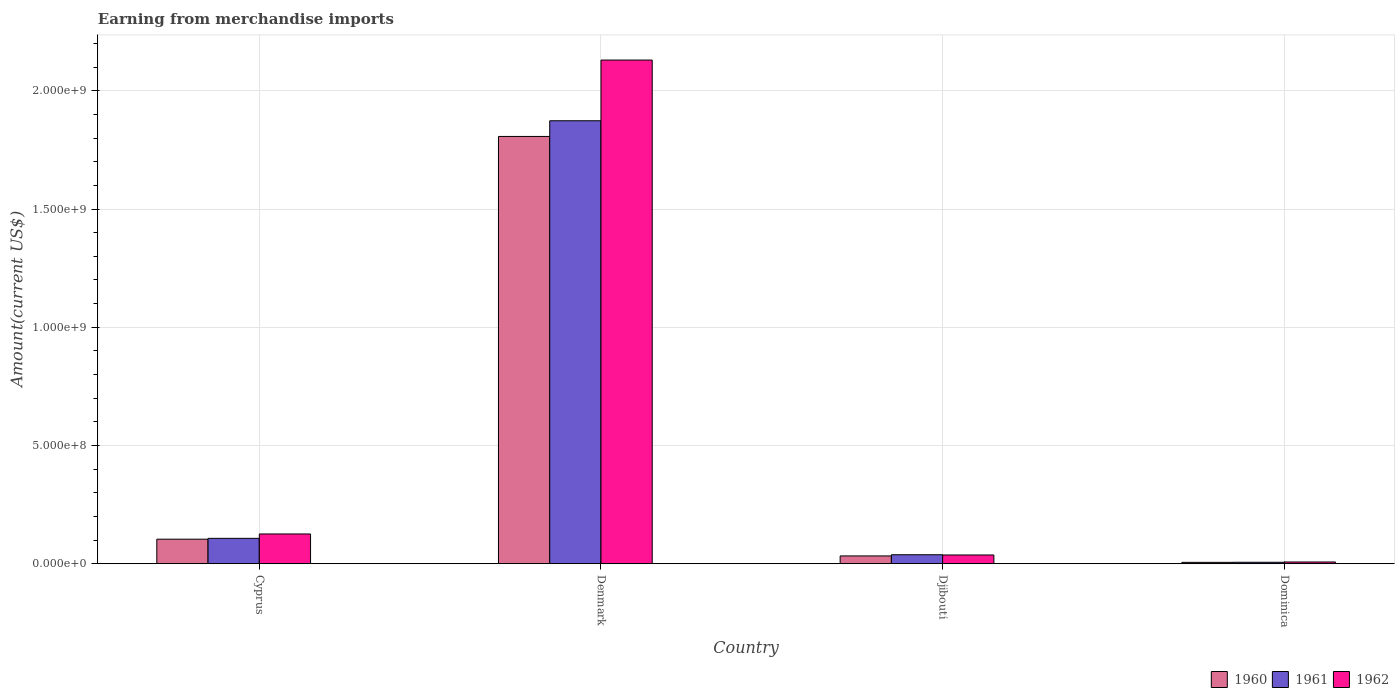How many different coloured bars are there?
Your answer should be very brief. 3. How many groups of bars are there?
Your answer should be compact. 4. How many bars are there on the 2nd tick from the right?
Ensure brevity in your answer.  3. In how many cases, is the number of bars for a given country not equal to the number of legend labels?
Give a very brief answer. 0. What is the amount earned from merchandise imports in 1960 in Cyprus?
Provide a short and direct response. 1.04e+08. Across all countries, what is the maximum amount earned from merchandise imports in 1962?
Offer a terse response. 2.13e+09. Across all countries, what is the minimum amount earned from merchandise imports in 1960?
Keep it short and to the point. 5.81e+06. In which country was the amount earned from merchandise imports in 1962 minimum?
Make the answer very short. Dominica. What is the total amount earned from merchandise imports in 1962 in the graph?
Your response must be concise. 2.30e+09. What is the difference between the amount earned from merchandise imports in 1962 in Cyprus and that in Djibouti?
Ensure brevity in your answer.  8.89e+07. What is the difference between the amount earned from merchandise imports in 1961 in Denmark and the amount earned from merchandise imports in 1960 in Dominica?
Provide a short and direct response. 1.87e+09. What is the average amount earned from merchandise imports in 1960 per country?
Provide a succinct answer. 4.87e+08. What is the difference between the amount earned from merchandise imports of/in 1960 and amount earned from merchandise imports of/in 1961 in Denmark?
Offer a terse response. -6.63e+07. What is the ratio of the amount earned from merchandise imports in 1962 in Cyprus to that in Dominica?
Your response must be concise. 16.98. What is the difference between the highest and the second highest amount earned from merchandise imports in 1960?
Your answer should be very brief. 1.77e+09. What is the difference between the highest and the lowest amount earned from merchandise imports in 1960?
Provide a succinct answer. 1.80e+09. In how many countries, is the amount earned from merchandise imports in 1960 greater than the average amount earned from merchandise imports in 1960 taken over all countries?
Your answer should be compact. 1. What does the 2nd bar from the left in Dominica represents?
Give a very brief answer. 1961. How many bars are there?
Make the answer very short. 12. Are all the bars in the graph horizontal?
Keep it short and to the point. No. How many countries are there in the graph?
Provide a succinct answer. 4. What is the difference between two consecutive major ticks on the Y-axis?
Provide a short and direct response. 5.00e+08. Does the graph contain any zero values?
Your answer should be compact. No. How many legend labels are there?
Your response must be concise. 3. How are the legend labels stacked?
Offer a terse response. Horizontal. What is the title of the graph?
Keep it short and to the point. Earning from merchandise imports. What is the label or title of the X-axis?
Make the answer very short. Country. What is the label or title of the Y-axis?
Make the answer very short. Amount(current US$). What is the Amount(current US$) in 1960 in Cyprus?
Provide a succinct answer. 1.04e+08. What is the Amount(current US$) in 1961 in Cyprus?
Make the answer very short. 1.07e+08. What is the Amount(current US$) in 1962 in Cyprus?
Provide a short and direct response. 1.26e+08. What is the Amount(current US$) of 1960 in Denmark?
Offer a very short reply. 1.81e+09. What is the Amount(current US$) of 1961 in Denmark?
Make the answer very short. 1.87e+09. What is the Amount(current US$) of 1962 in Denmark?
Your response must be concise. 2.13e+09. What is the Amount(current US$) of 1960 in Djibouti?
Your response must be concise. 3.30e+07. What is the Amount(current US$) in 1961 in Djibouti?
Provide a short and direct response. 3.80e+07. What is the Amount(current US$) in 1962 in Djibouti?
Offer a terse response. 3.70e+07. What is the Amount(current US$) of 1960 in Dominica?
Provide a succinct answer. 5.81e+06. What is the Amount(current US$) of 1961 in Dominica?
Ensure brevity in your answer.  6.17e+06. What is the Amount(current US$) of 1962 in Dominica?
Provide a short and direct response. 7.41e+06. Across all countries, what is the maximum Amount(current US$) in 1960?
Keep it short and to the point. 1.81e+09. Across all countries, what is the maximum Amount(current US$) of 1961?
Make the answer very short. 1.87e+09. Across all countries, what is the maximum Amount(current US$) of 1962?
Provide a succinct answer. 2.13e+09. Across all countries, what is the minimum Amount(current US$) in 1960?
Your answer should be very brief. 5.81e+06. Across all countries, what is the minimum Amount(current US$) in 1961?
Give a very brief answer. 6.17e+06. Across all countries, what is the minimum Amount(current US$) in 1962?
Offer a terse response. 7.41e+06. What is the total Amount(current US$) in 1960 in the graph?
Keep it short and to the point. 1.95e+09. What is the total Amount(current US$) of 1961 in the graph?
Offer a terse response. 2.02e+09. What is the total Amount(current US$) of 1962 in the graph?
Offer a very short reply. 2.30e+09. What is the difference between the Amount(current US$) in 1960 in Cyprus and that in Denmark?
Offer a very short reply. -1.70e+09. What is the difference between the Amount(current US$) in 1961 in Cyprus and that in Denmark?
Provide a succinct answer. -1.77e+09. What is the difference between the Amount(current US$) of 1962 in Cyprus and that in Denmark?
Your answer should be very brief. -2.00e+09. What is the difference between the Amount(current US$) of 1960 in Cyprus and that in Djibouti?
Ensure brevity in your answer.  7.08e+07. What is the difference between the Amount(current US$) in 1961 in Cyprus and that in Djibouti?
Your answer should be compact. 6.93e+07. What is the difference between the Amount(current US$) in 1962 in Cyprus and that in Djibouti?
Keep it short and to the point. 8.89e+07. What is the difference between the Amount(current US$) of 1960 in Cyprus and that in Dominica?
Give a very brief answer. 9.80e+07. What is the difference between the Amount(current US$) of 1961 in Cyprus and that in Dominica?
Provide a succinct answer. 1.01e+08. What is the difference between the Amount(current US$) in 1962 in Cyprus and that in Dominica?
Your answer should be compact. 1.18e+08. What is the difference between the Amount(current US$) in 1960 in Denmark and that in Djibouti?
Offer a very short reply. 1.77e+09. What is the difference between the Amount(current US$) in 1961 in Denmark and that in Djibouti?
Provide a short and direct response. 1.84e+09. What is the difference between the Amount(current US$) of 1962 in Denmark and that in Djibouti?
Offer a very short reply. 2.09e+09. What is the difference between the Amount(current US$) in 1960 in Denmark and that in Dominica?
Keep it short and to the point. 1.80e+09. What is the difference between the Amount(current US$) of 1961 in Denmark and that in Dominica?
Your answer should be compact. 1.87e+09. What is the difference between the Amount(current US$) in 1962 in Denmark and that in Dominica?
Keep it short and to the point. 2.12e+09. What is the difference between the Amount(current US$) in 1960 in Djibouti and that in Dominica?
Give a very brief answer. 2.72e+07. What is the difference between the Amount(current US$) in 1961 in Djibouti and that in Dominica?
Make the answer very short. 3.18e+07. What is the difference between the Amount(current US$) in 1962 in Djibouti and that in Dominica?
Provide a succinct answer. 2.96e+07. What is the difference between the Amount(current US$) in 1960 in Cyprus and the Amount(current US$) in 1961 in Denmark?
Your answer should be very brief. -1.77e+09. What is the difference between the Amount(current US$) in 1960 in Cyprus and the Amount(current US$) in 1962 in Denmark?
Your answer should be very brief. -2.03e+09. What is the difference between the Amount(current US$) of 1961 in Cyprus and the Amount(current US$) of 1962 in Denmark?
Keep it short and to the point. -2.02e+09. What is the difference between the Amount(current US$) of 1960 in Cyprus and the Amount(current US$) of 1961 in Djibouti?
Your answer should be very brief. 6.58e+07. What is the difference between the Amount(current US$) in 1960 in Cyprus and the Amount(current US$) in 1962 in Djibouti?
Your answer should be very brief. 6.68e+07. What is the difference between the Amount(current US$) of 1961 in Cyprus and the Amount(current US$) of 1962 in Djibouti?
Ensure brevity in your answer.  7.03e+07. What is the difference between the Amount(current US$) in 1960 in Cyprus and the Amount(current US$) in 1961 in Dominica?
Your response must be concise. 9.76e+07. What is the difference between the Amount(current US$) of 1960 in Cyprus and the Amount(current US$) of 1962 in Dominica?
Your response must be concise. 9.64e+07. What is the difference between the Amount(current US$) of 1961 in Cyprus and the Amount(current US$) of 1962 in Dominica?
Keep it short and to the point. 9.99e+07. What is the difference between the Amount(current US$) in 1960 in Denmark and the Amount(current US$) in 1961 in Djibouti?
Keep it short and to the point. 1.77e+09. What is the difference between the Amount(current US$) in 1960 in Denmark and the Amount(current US$) in 1962 in Djibouti?
Provide a short and direct response. 1.77e+09. What is the difference between the Amount(current US$) of 1961 in Denmark and the Amount(current US$) of 1962 in Djibouti?
Your answer should be compact. 1.84e+09. What is the difference between the Amount(current US$) in 1960 in Denmark and the Amount(current US$) in 1961 in Dominica?
Make the answer very short. 1.80e+09. What is the difference between the Amount(current US$) of 1960 in Denmark and the Amount(current US$) of 1962 in Dominica?
Offer a very short reply. 1.80e+09. What is the difference between the Amount(current US$) in 1961 in Denmark and the Amount(current US$) in 1962 in Dominica?
Provide a succinct answer. 1.87e+09. What is the difference between the Amount(current US$) of 1960 in Djibouti and the Amount(current US$) of 1961 in Dominica?
Give a very brief answer. 2.68e+07. What is the difference between the Amount(current US$) in 1960 in Djibouti and the Amount(current US$) in 1962 in Dominica?
Your answer should be very brief. 2.56e+07. What is the difference between the Amount(current US$) in 1961 in Djibouti and the Amount(current US$) in 1962 in Dominica?
Make the answer very short. 3.06e+07. What is the average Amount(current US$) in 1960 per country?
Ensure brevity in your answer.  4.87e+08. What is the average Amount(current US$) in 1961 per country?
Your answer should be compact. 5.06e+08. What is the average Amount(current US$) of 1962 per country?
Give a very brief answer. 5.75e+08. What is the difference between the Amount(current US$) in 1960 and Amount(current US$) in 1961 in Cyprus?
Keep it short and to the point. -3.52e+06. What is the difference between the Amount(current US$) of 1960 and Amount(current US$) of 1962 in Cyprus?
Your answer should be compact. -2.21e+07. What is the difference between the Amount(current US$) of 1961 and Amount(current US$) of 1962 in Cyprus?
Your answer should be compact. -1.85e+07. What is the difference between the Amount(current US$) in 1960 and Amount(current US$) in 1961 in Denmark?
Give a very brief answer. -6.63e+07. What is the difference between the Amount(current US$) in 1960 and Amount(current US$) in 1962 in Denmark?
Offer a terse response. -3.23e+08. What is the difference between the Amount(current US$) of 1961 and Amount(current US$) of 1962 in Denmark?
Provide a short and direct response. -2.57e+08. What is the difference between the Amount(current US$) of 1960 and Amount(current US$) of 1961 in Djibouti?
Give a very brief answer. -5.00e+06. What is the difference between the Amount(current US$) of 1960 and Amount(current US$) of 1961 in Dominica?
Your response must be concise. -3.58e+05. What is the difference between the Amount(current US$) in 1960 and Amount(current US$) in 1962 in Dominica?
Give a very brief answer. -1.60e+06. What is the difference between the Amount(current US$) in 1961 and Amount(current US$) in 1962 in Dominica?
Ensure brevity in your answer.  -1.24e+06. What is the ratio of the Amount(current US$) of 1960 in Cyprus to that in Denmark?
Offer a very short reply. 0.06. What is the ratio of the Amount(current US$) in 1961 in Cyprus to that in Denmark?
Ensure brevity in your answer.  0.06. What is the ratio of the Amount(current US$) of 1962 in Cyprus to that in Denmark?
Give a very brief answer. 0.06. What is the ratio of the Amount(current US$) in 1960 in Cyprus to that in Djibouti?
Keep it short and to the point. 3.15. What is the ratio of the Amount(current US$) in 1961 in Cyprus to that in Djibouti?
Offer a very short reply. 2.82. What is the ratio of the Amount(current US$) in 1962 in Cyprus to that in Djibouti?
Give a very brief answer. 3.4. What is the ratio of the Amount(current US$) in 1960 in Cyprus to that in Dominica?
Your answer should be very brief. 17.86. What is the ratio of the Amount(current US$) of 1961 in Cyprus to that in Dominica?
Ensure brevity in your answer.  17.4. What is the ratio of the Amount(current US$) of 1962 in Cyprus to that in Dominica?
Provide a succinct answer. 16.98. What is the ratio of the Amount(current US$) of 1960 in Denmark to that in Djibouti?
Provide a succinct answer. 54.76. What is the ratio of the Amount(current US$) in 1961 in Denmark to that in Djibouti?
Your response must be concise. 49.3. What is the ratio of the Amount(current US$) of 1962 in Denmark to that in Djibouti?
Offer a very short reply. 57.57. What is the ratio of the Amount(current US$) of 1960 in Denmark to that in Dominica?
Provide a short and direct response. 310.89. What is the ratio of the Amount(current US$) of 1961 in Denmark to that in Dominica?
Your answer should be compact. 303.62. What is the ratio of the Amount(current US$) of 1962 in Denmark to that in Dominica?
Offer a terse response. 287.33. What is the ratio of the Amount(current US$) of 1960 in Djibouti to that in Dominica?
Provide a short and direct response. 5.68. What is the ratio of the Amount(current US$) of 1961 in Djibouti to that in Dominica?
Ensure brevity in your answer.  6.16. What is the ratio of the Amount(current US$) in 1962 in Djibouti to that in Dominica?
Ensure brevity in your answer.  4.99. What is the difference between the highest and the second highest Amount(current US$) of 1960?
Make the answer very short. 1.70e+09. What is the difference between the highest and the second highest Amount(current US$) in 1961?
Keep it short and to the point. 1.77e+09. What is the difference between the highest and the second highest Amount(current US$) in 1962?
Offer a terse response. 2.00e+09. What is the difference between the highest and the lowest Amount(current US$) of 1960?
Your answer should be compact. 1.80e+09. What is the difference between the highest and the lowest Amount(current US$) of 1961?
Provide a succinct answer. 1.87e+09. What is the difference between the highest and the lowest Amount(current US$) in 1962?
Provide a succinct answer. 2.12e+09. 